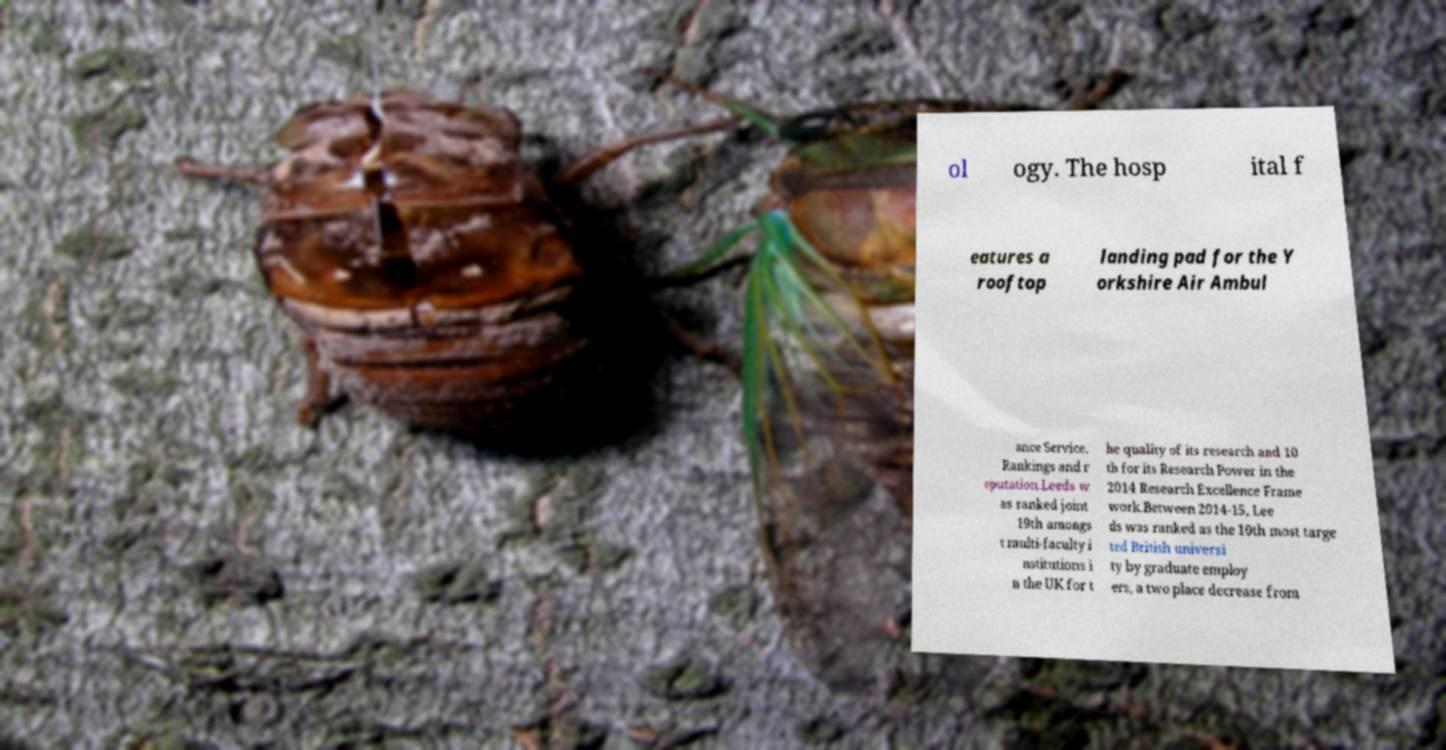Could you extract and type out the text from this image? ol ogy. The hosp ital f eatures a rooftop landing pad for the Y orkshire Air Ambul ance Service. Rankings and r eputation.Leeds w as ranked joint 19th amongs t multi-faculty i nstitutions i n the UK for t he quality of its research and 10 th for its Research Power in the 2014 Research Excellence Frame work.Between 2014-15, Lee ds was ranked as the 10th most targe ted British universi ty by graduate employ ers, a two place decrease from 